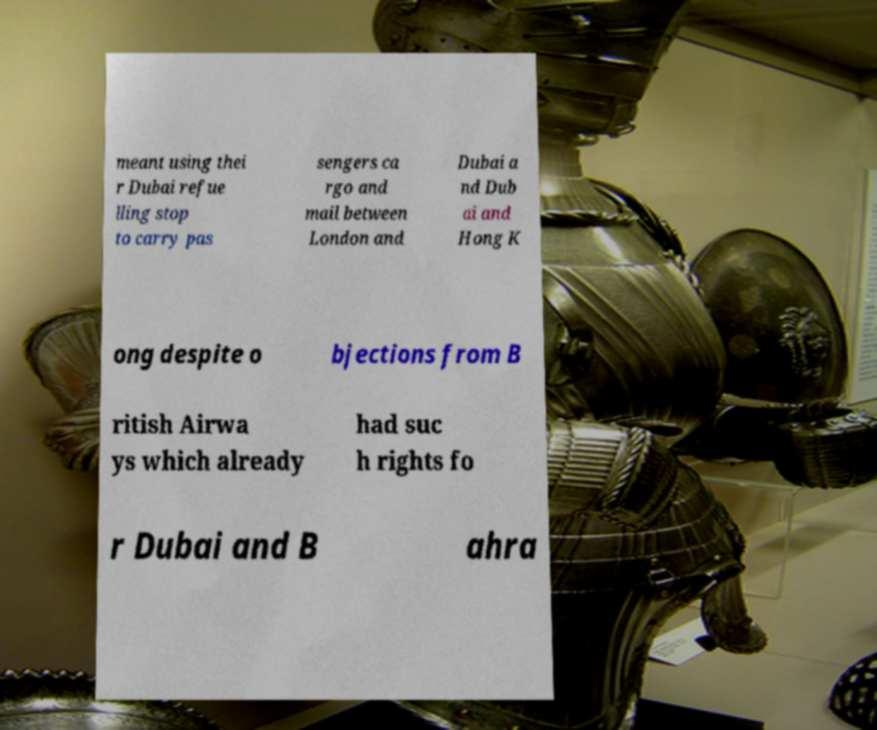There's text embedded in this image that I need extracted. Can you transcribe it verbatim? meant using thei r Dubai refue lling stop to carry pas sengers ca rgo and mail between London and Dubai a nd Dub ai and Hong K ong despite o bjections from B ritish Airwa ys which already had suc h rights fo r Dubai and B ahra 